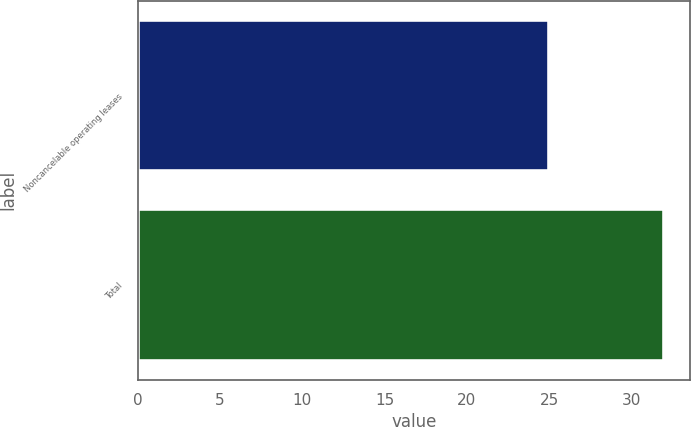<chart> <loc_0><loc_0><loc_500><loc_500><bar_chart><fcel>Noncancelable operating leases<fcel>Total<nl><fcel>25<fcel>32<nl></chart> 